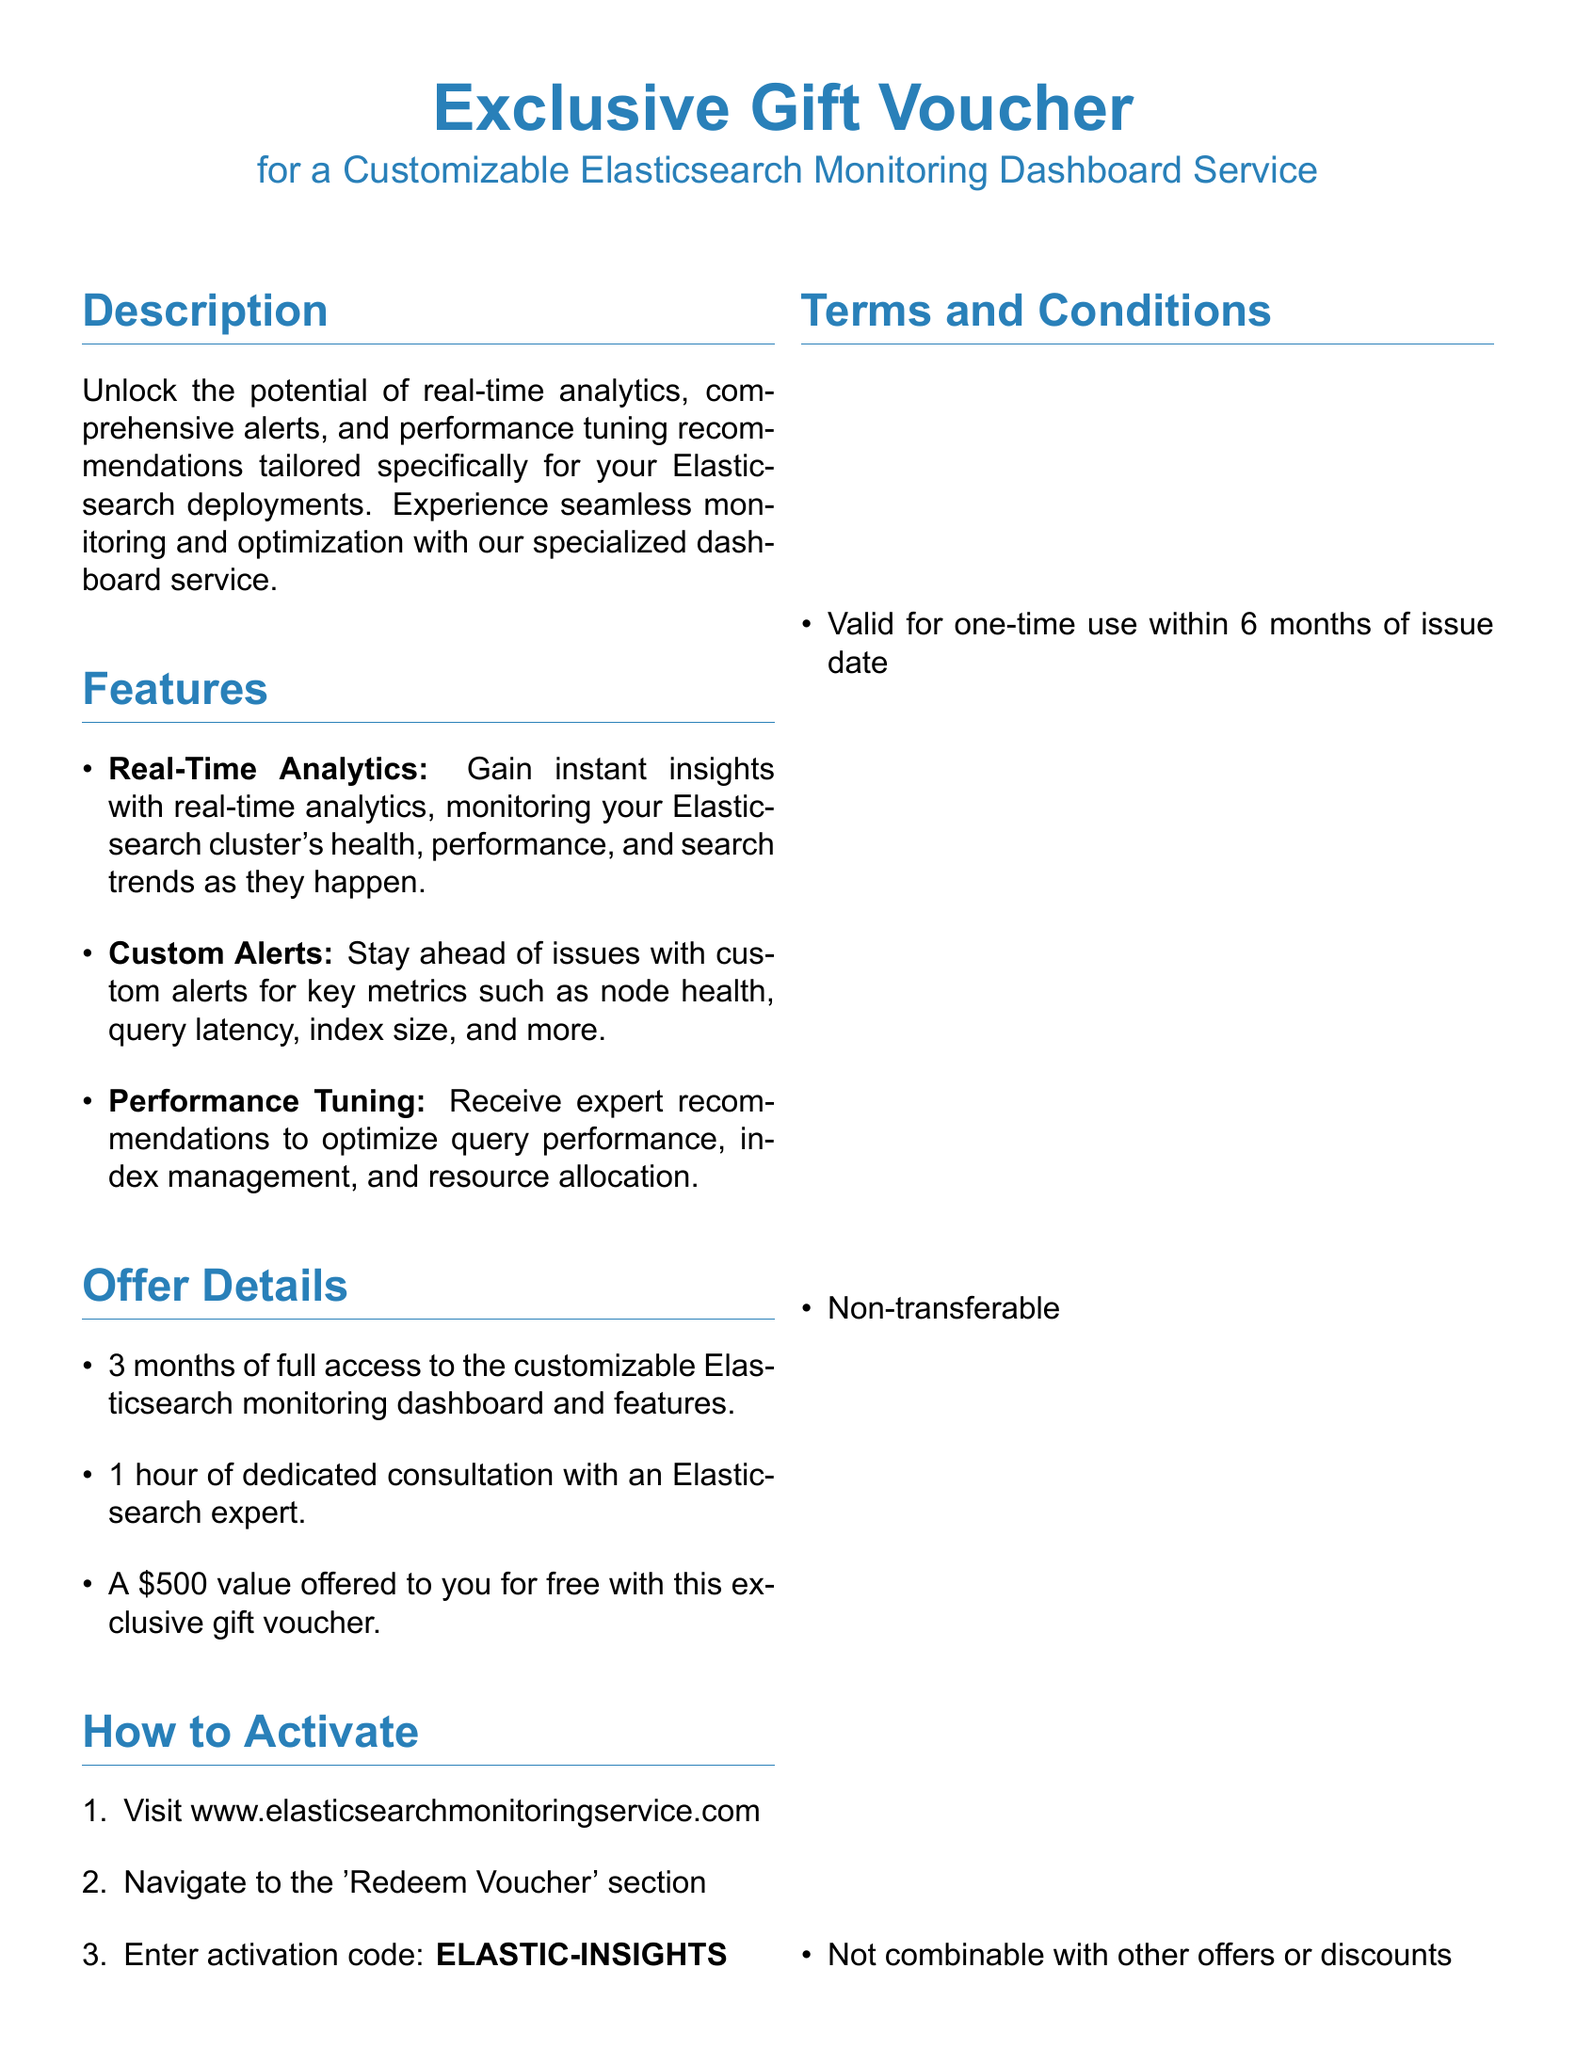what is the activation code? The activation code required to redeem the voucher is specified in the document.
Answer: ELASTIC-INSIGHTS how many months of access does the voucher provide? The length of access to the customizable Elasticsearch monitoring dashboard is mentioned in the offer details.
Answer: 3 months what is the value of the offer provided by the voucher? The document states the monetary value of the offer that comes with the gift voucher.
Answer: $500 what should you do to activate the voucher? The steps to activate the gift voucher are listed in the document, outlining the required actions.
Answer: Visit www.elasticsearchmonitoringservice.com, Navigate to the 'Redeem Voucher' section, Enter activation code who can you contact for support regarding the service? The document provides a contact email for support related to the service offered.
Answer: support@elasticsearchmonitoringservice.com is the voucher transferable? The terms and conditions section states whether the voucher can be transferred to another person.
Answer: Non-transferable what type of insights does the service provide? The features section outlines the nature of insights the service delivers regarding Elasticsearch performance.
Answer: Real-Time Analytics who is the service primarily aimed at? The document indicates the intended audience for the Elasticsearch monitoring dashboard service.
Answer: Technology bloggers 